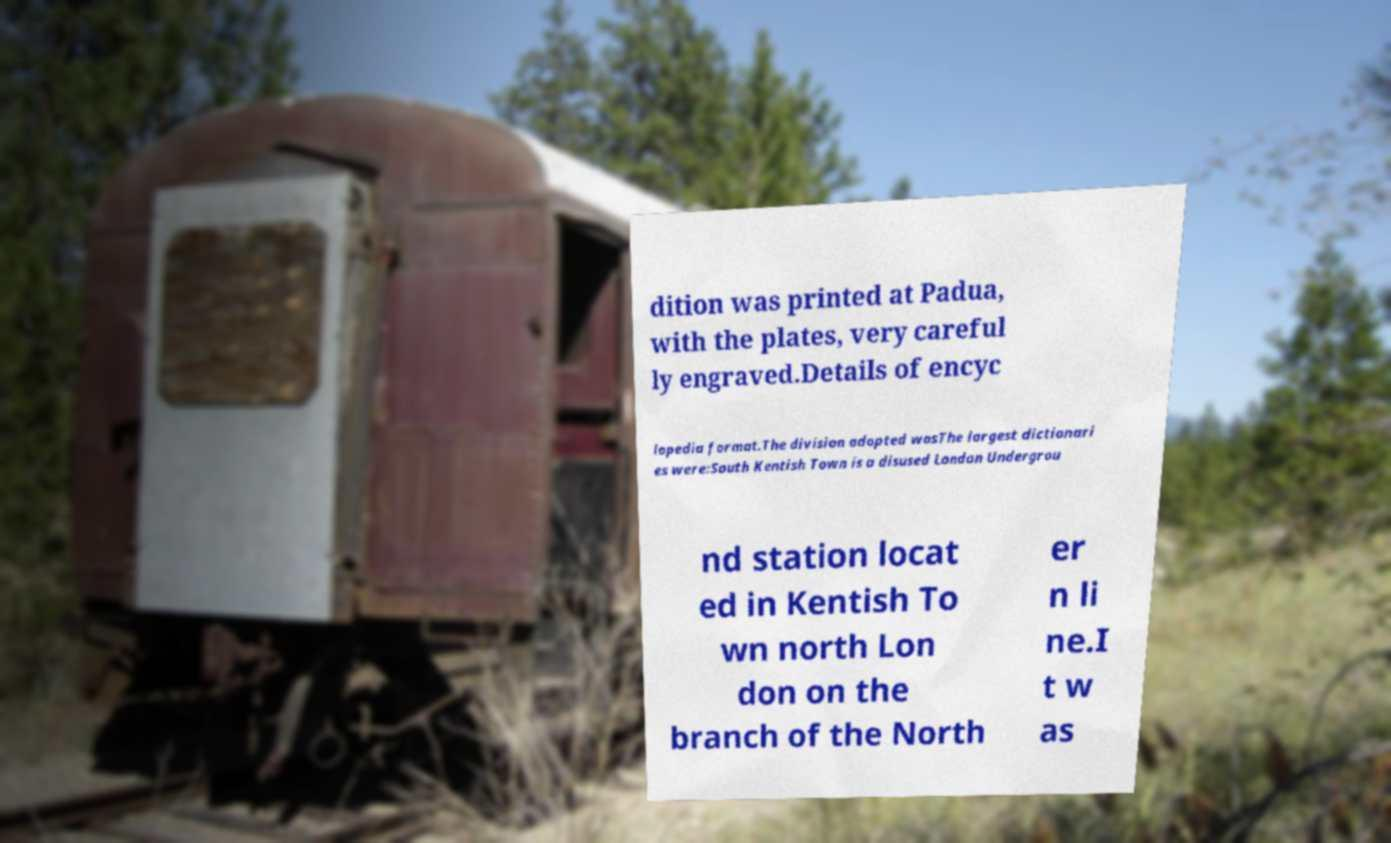For documentation purposes, I need the text within this image transcribed. Could you provide that? dition was printed at Padua, with the plates, very careful ly engraved.Details of encyc lopedia format.The division adopted wasThe largest dictionari es were:South Kentish Town is a disused London Undergrou nd station locat ed in Kentish To wn north Lon don on the branch of the North er n li ne.I t w as 